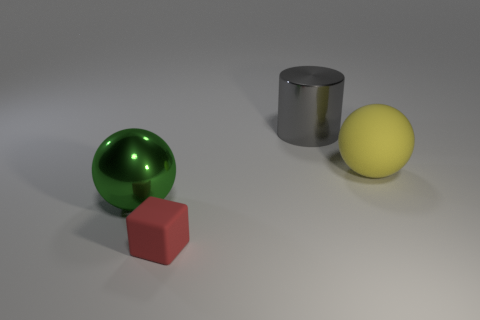Hypothetically, if these objects represented planets, which one might resemble Earth and why? If hypothetically these objects represented planets, the green sphere might resemble Earth due to its vibrant color, which could be associated with Earth's lush landscapes and oceans. 